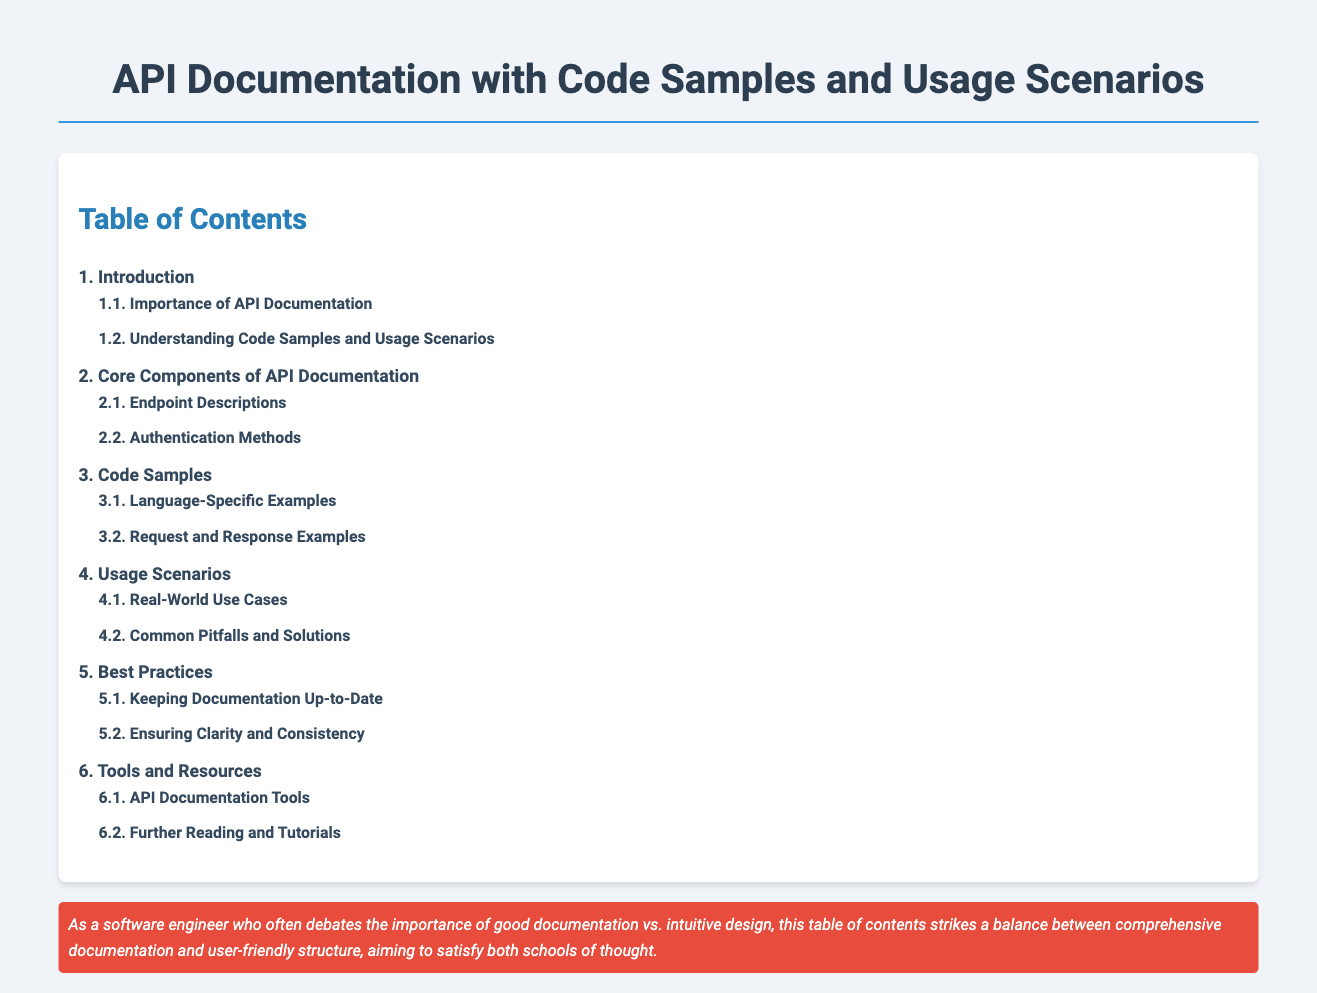What is the first section in the table of contents? The first section listed is "1. Introduction."
Answer: 1. Introduction How many main topics are listed in the table of contents? There are six main topics in the table of contents.
Answer: 6 What is the last subtopic under "Usage Scenarios"? The last subtopic under "Usage Scenarios" is "4.2. Common Pitfalls and Solutions."
Answer: 4.2. Common Pitfalls and Solutions Which section includes information on "Authentication Methods"? Information on "Authentication Methods" is found in "2. Core Components of API Documentation."
Answer: 2. Core Components of API Documentation What does the persona note emphasize? The persona note emphasizes the balance between documentation and intuitive design.
Answer: Balance between documentation and intuitive design 